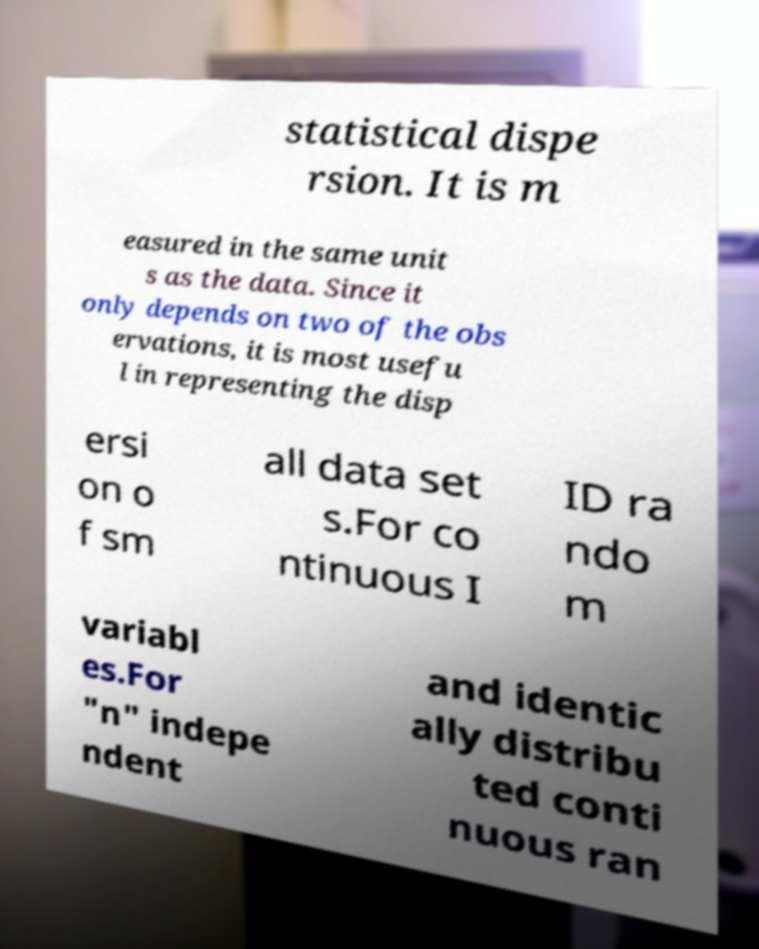Please identify and transcribe the text found in this image. statistical dispe rsion. It is m easured in the same unit s as the data. Since it only depends on two of the obs ervations, it is most usefu l in representing the disp ersi on o f sm all data set s.For co ntinuous I ID ra ndo m variabl es.For "n" indepe ndent and identic ally distribu ted conti nuous ran 